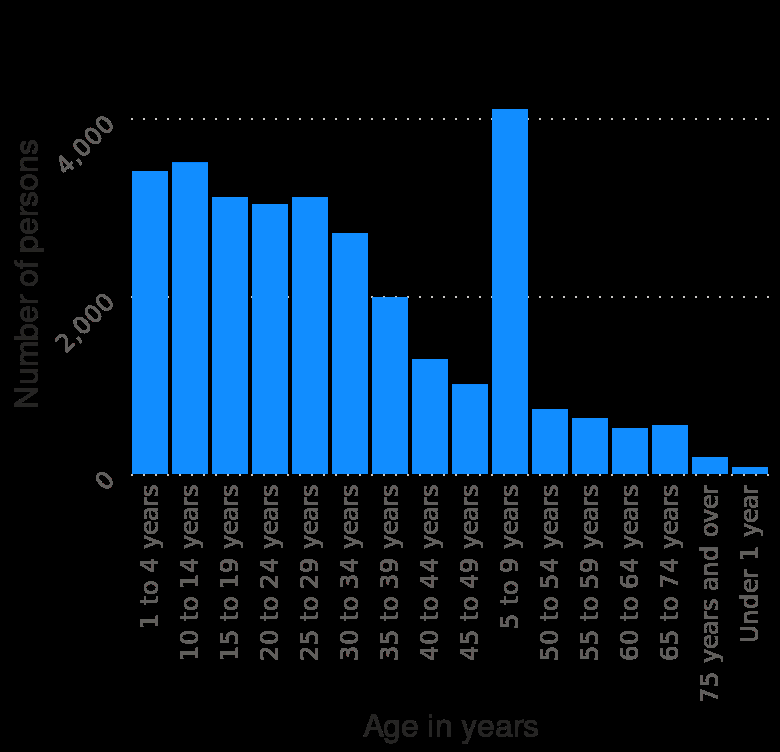<image>
What is the age range represented on the x-axis of the bar chart? The age range represented on the x-axis of the bar chart is from 1 to 4 years. please describe the details of the chart Number of refugees arriving in the United States in 2019 , by age is a bar chart. Along the y-axis, Number of persons is drawn as a linear scale of range 0 to 4,000. Along the x-axis, Age in years is shown as a categorical scale from 1 to 4 years to . please summary the statistics and relations of the chart A significantly higher number of refugees aged 5-9 years arrived in the US than in any other age group. The least represented age group amongst refugees is those under the age of 1; with those above the age of 75 being the second most underrepresented group. There are significantly more refugees under the age of 40 than there are over the age of 40. What is the scale range for the y-axis of the bar chart? The scale range for the y-axis of the bar chart is from 0 to 4,000. 